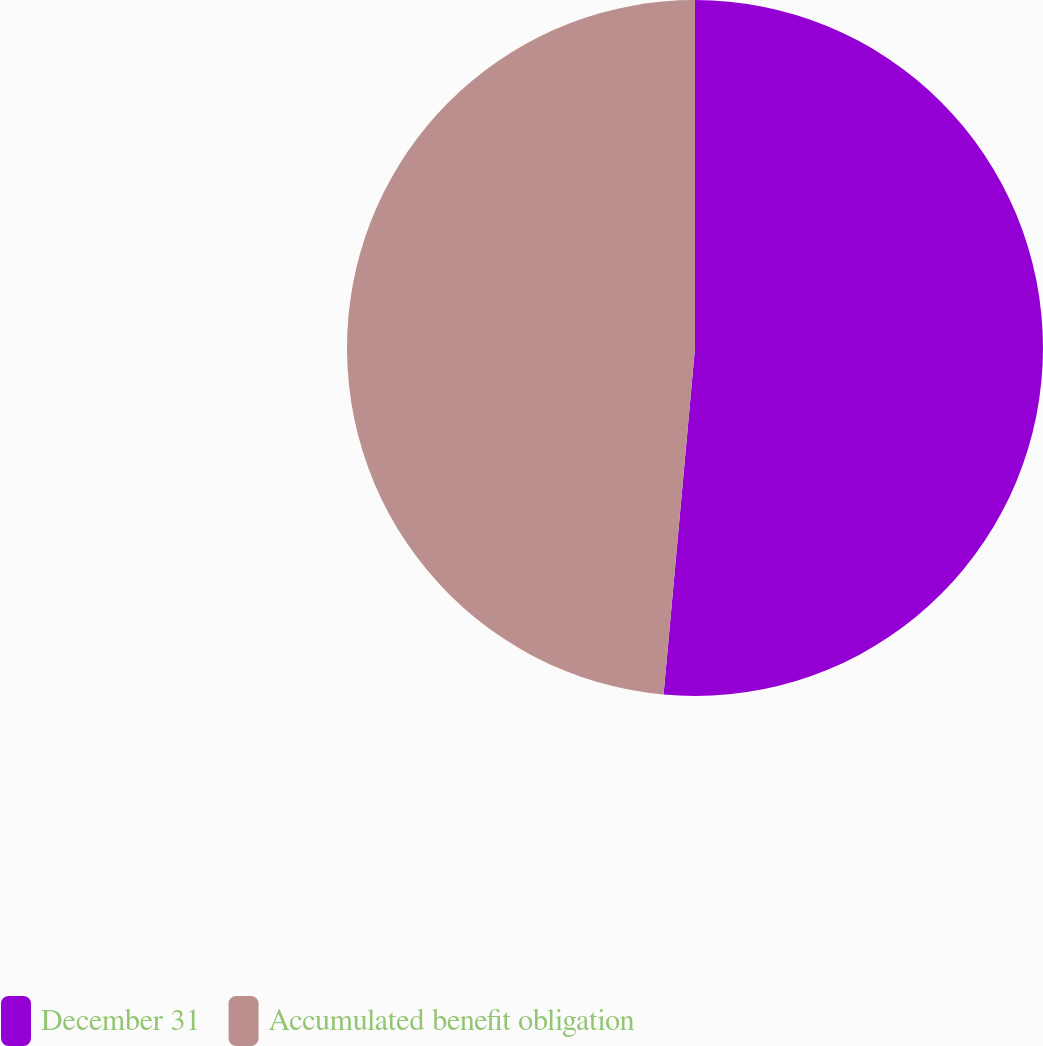Convert chart to OTSL. <chart><loc_0><loc_0><loc_500><loc_500><pie_chart><fcel>December 31<fcel>Accumulated benefit obligation<nl><fcel>51.44%<fcel>48.56%<nl></chart> 